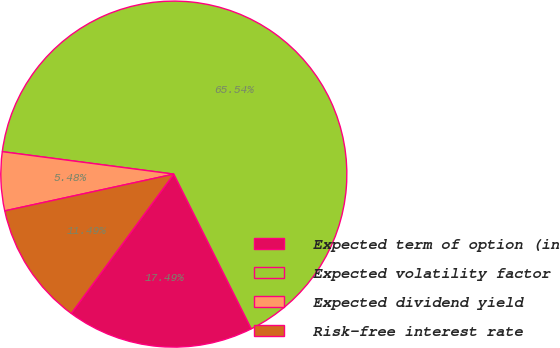Convert chart to OTSL. <chart><loc_0><loc_0><loc_500><loc_500><pie_chart><fcel>Expected term of option (in<fcel>Expected volatility factor<fcel>Expected dividend yield<fcel>Risk-free interest rate<nl><fcel>17.49%<fcel>65.54%<fcel>5.48%<fcel>11.49%<nl></chart> 